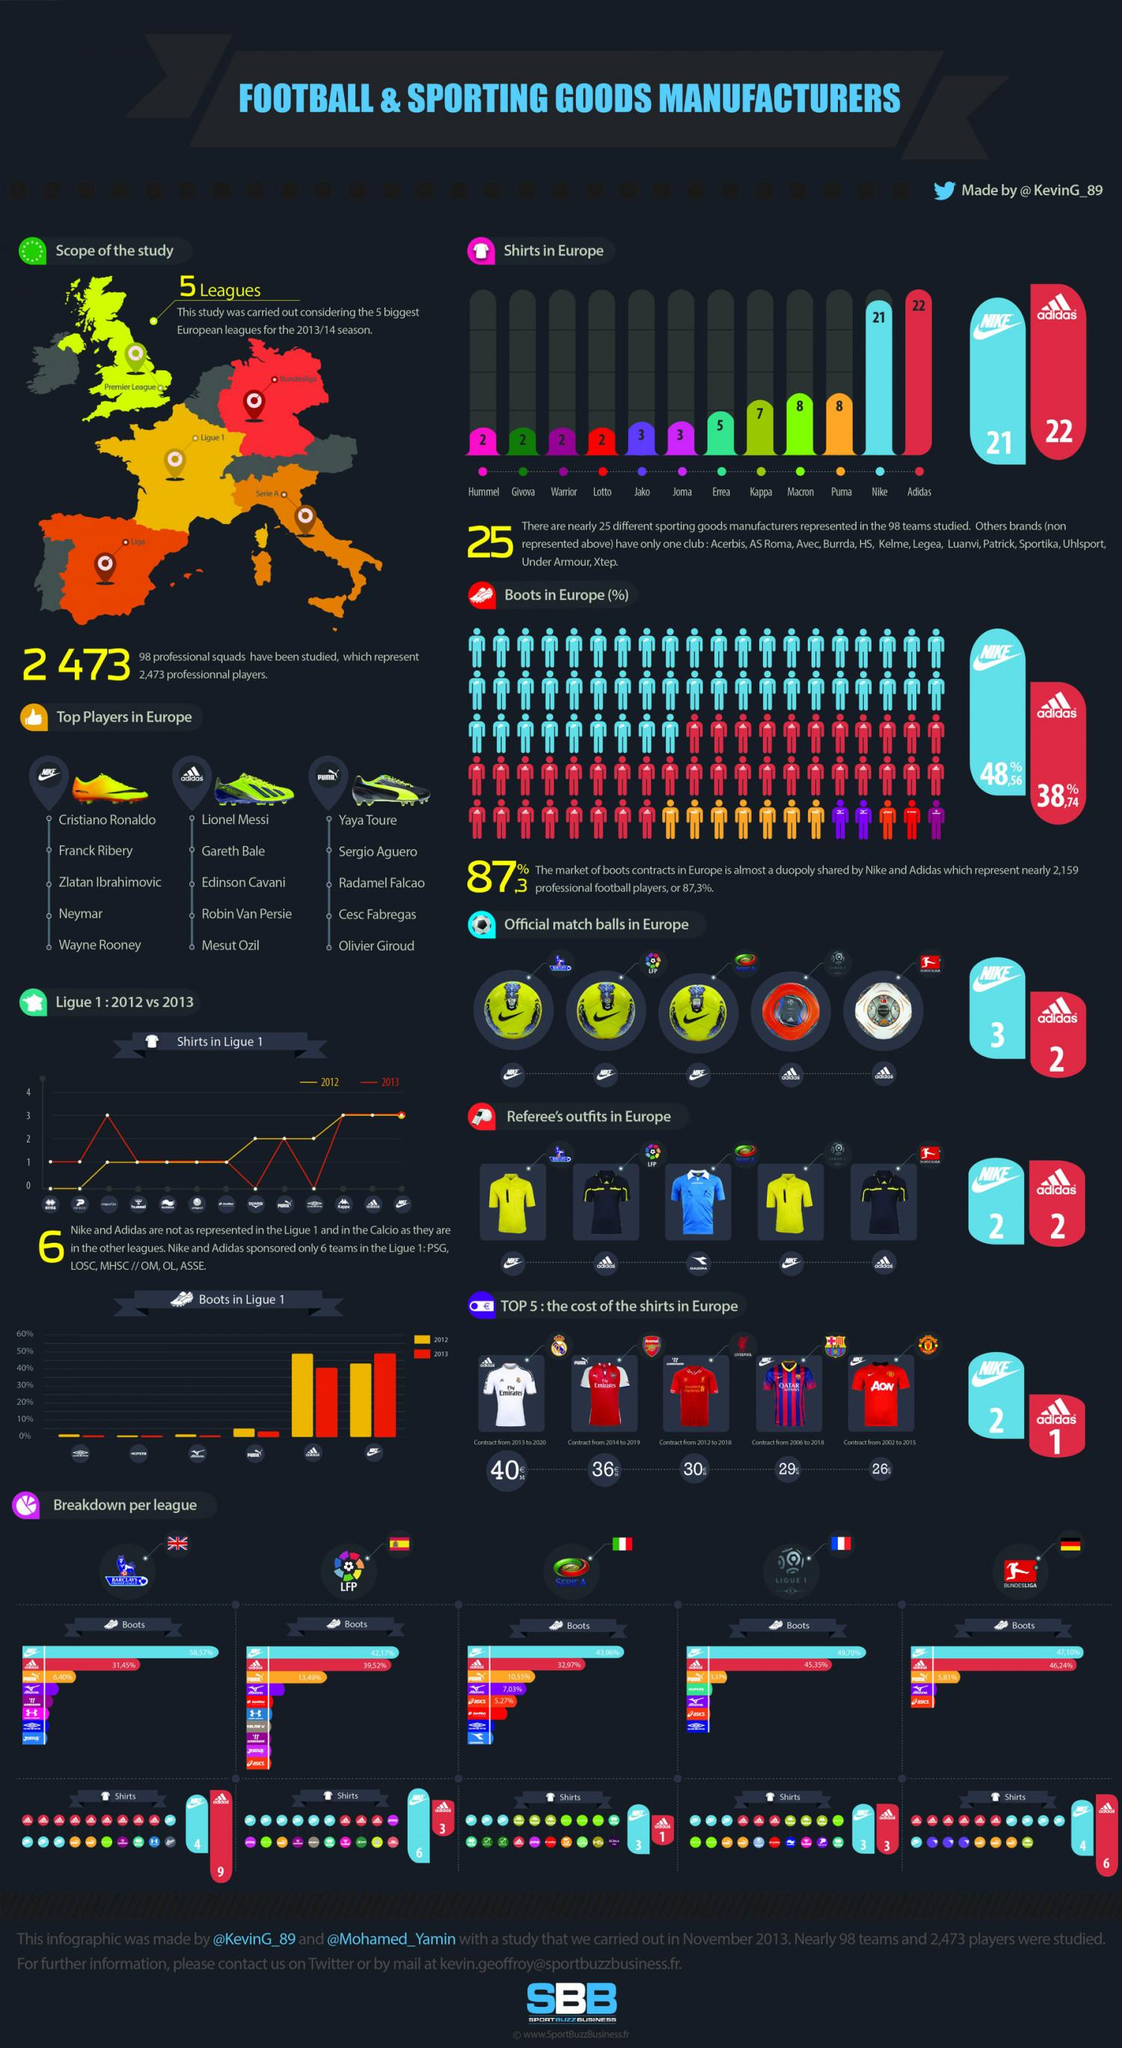Point out several critical features in this image. According to the information available, Puma has produced a total of 8 shirts in Europe. Adidas has a 38.74% share of the boot contracts market in Europe. Nike holds a 48.56% market share in Europe for boots contracts. Nike has produced 21 shirts in Europe. Adidas is the brand that produces the largest quantity of shirts in Europe. 